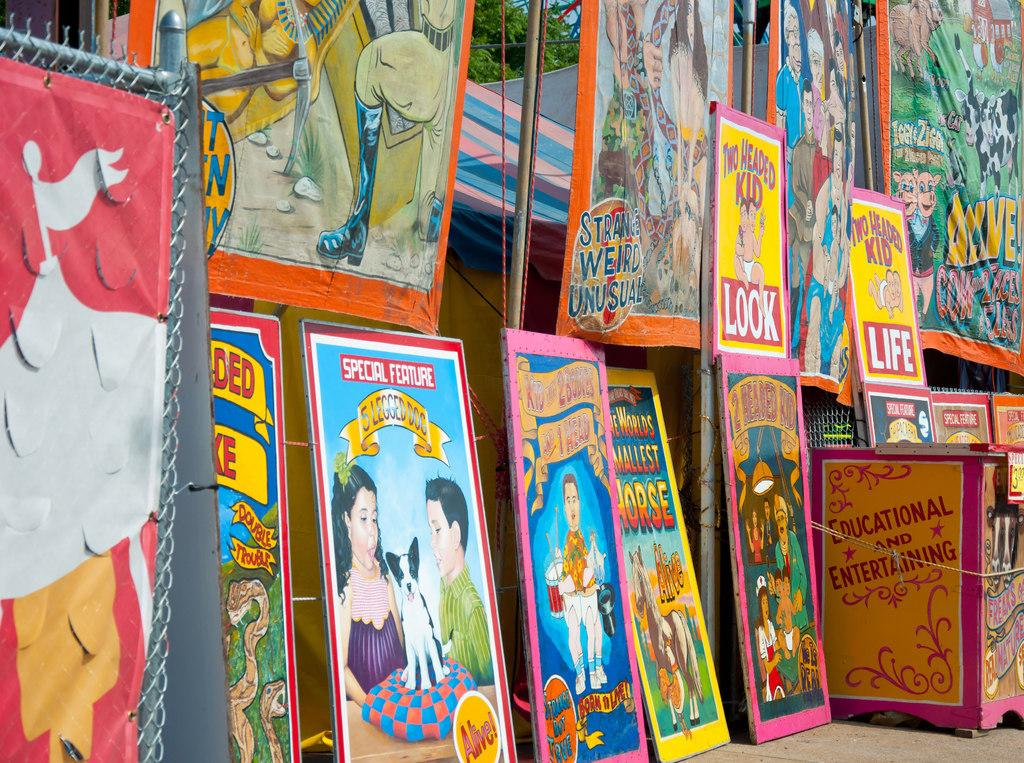<image>
Render a clear and concise summary of the photo. A card that says special feature at the top features a man and woman on it and sits with many other cards. 